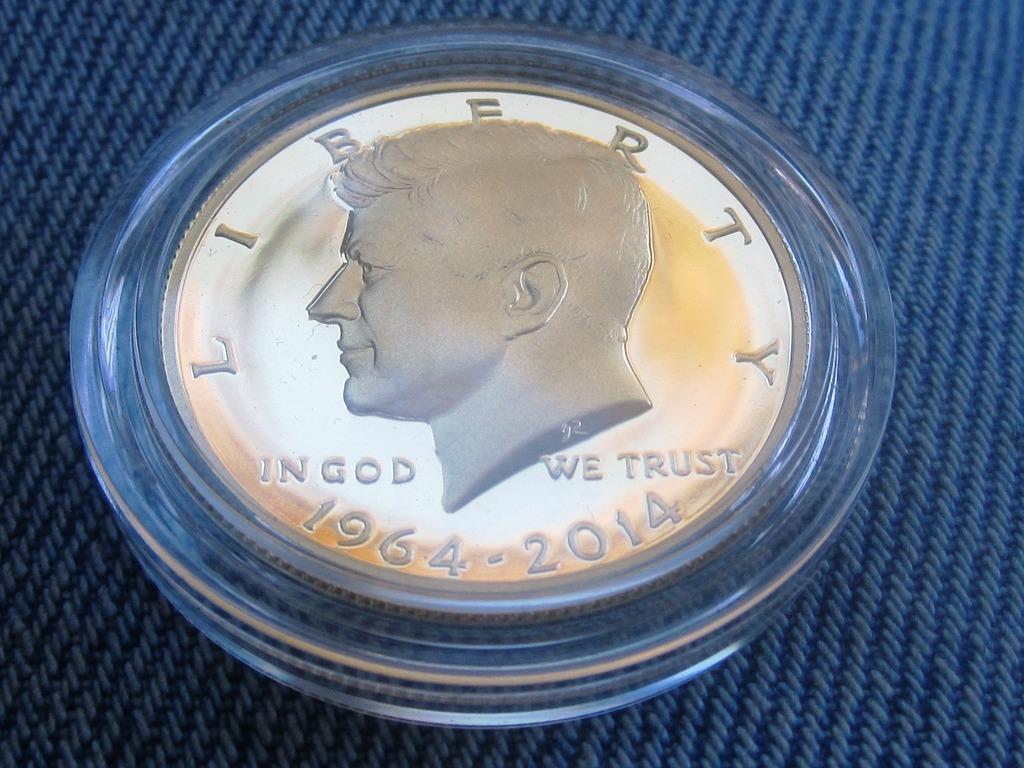Please provide a concise description of this image. In the middle of this image, there are letters and sculptures of a person on a coin which is placed in a glass item. This glass item is placed on a surface. And the background is gray in color. 